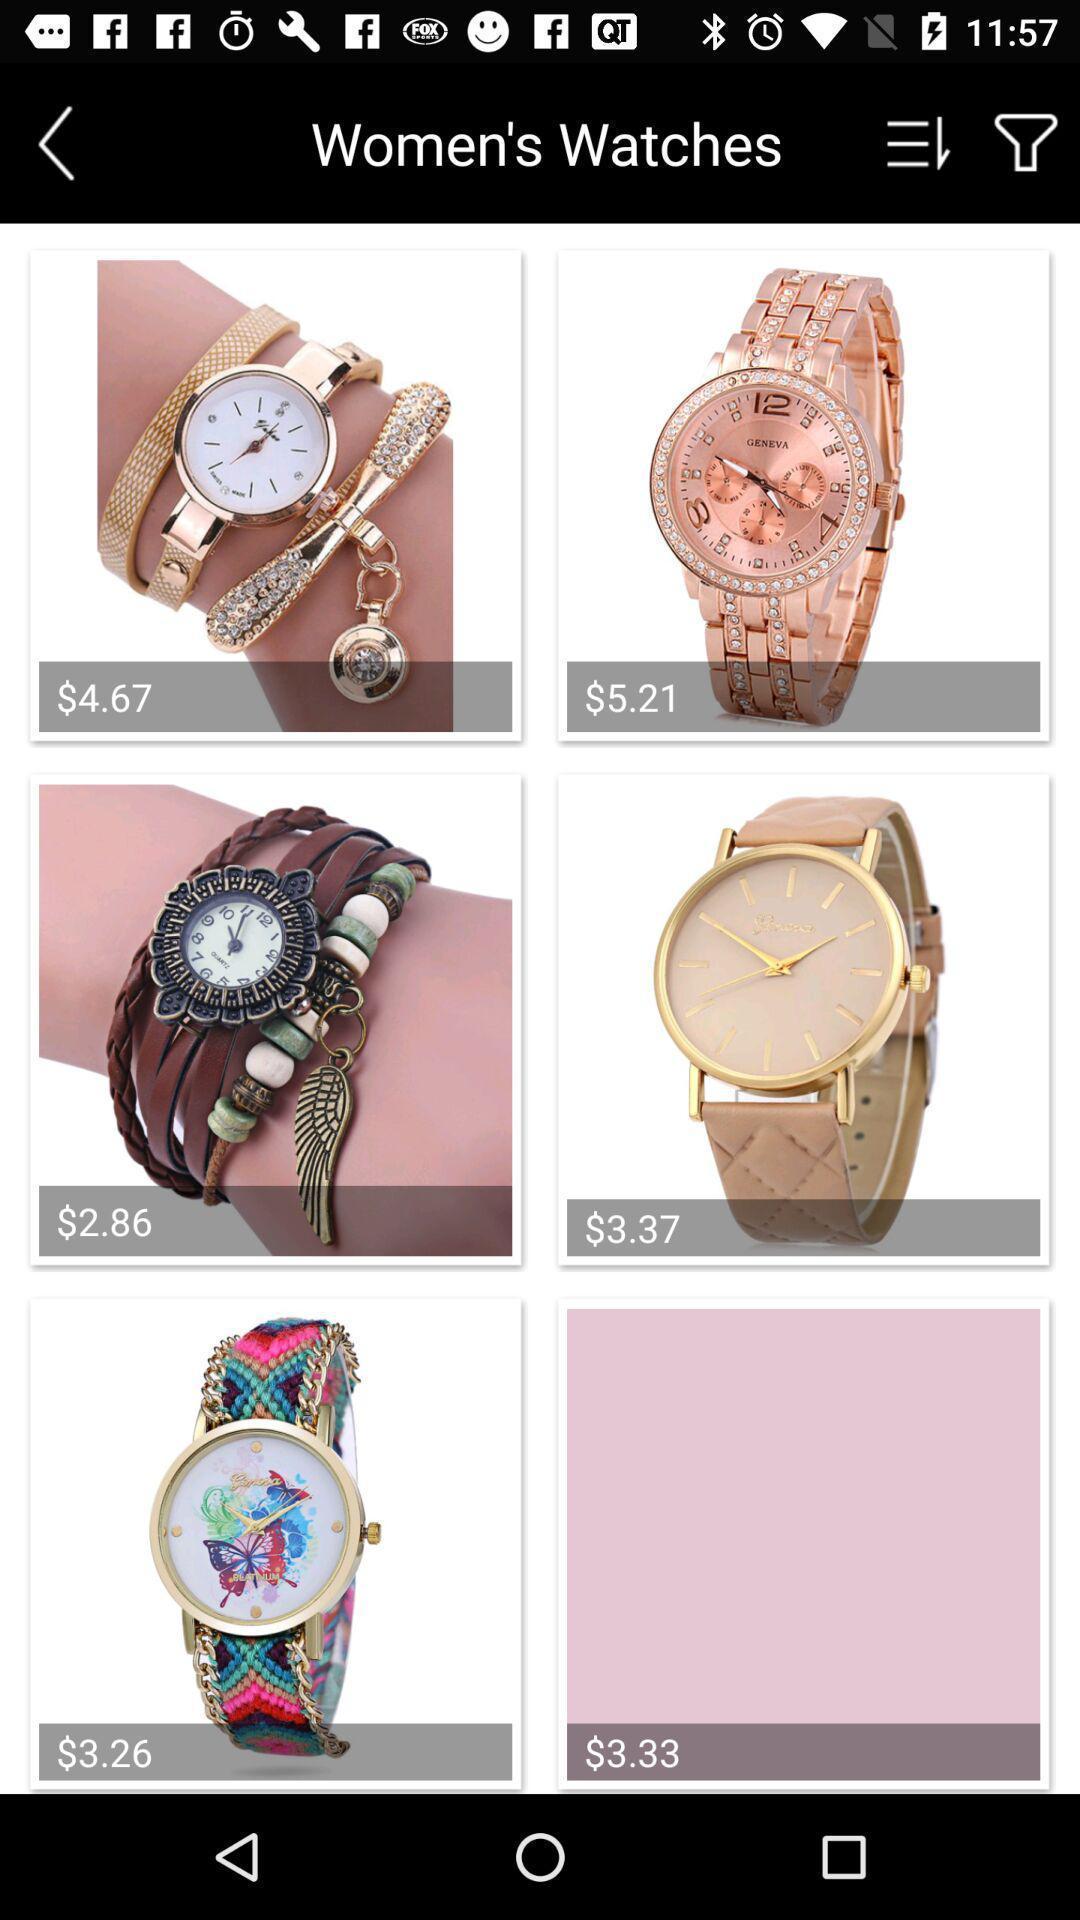Explain the elements present in this screenshot. Shopping application displayed different type of watches with price. 